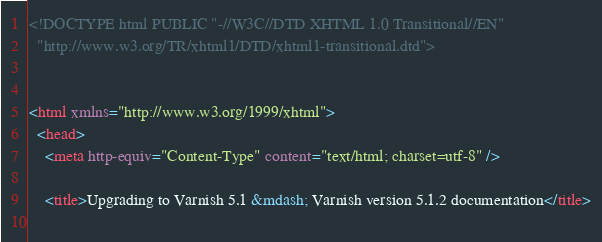Convert code to text. <code><loc_0><loc_0><loc_500><loc_500><_HTML_><!DOCTYPE html PUBLIC "-//W3C//DTD XHTML 1.0 Transitional//EN"
  "http://www.w3.org/TR/xhtml1/DTD/xhtml1-transitional.dtd">


<html xmlns="http://www.w3.org/1999/xhtml">
  <head>
    <meta http-equiv="Content-Type" content="text/html; charset=utf-8" />
    
    <title>Upgrading to Varnish 5.1 &mdash; Varnish version 5.1.2 documentation</title>
    </code> 